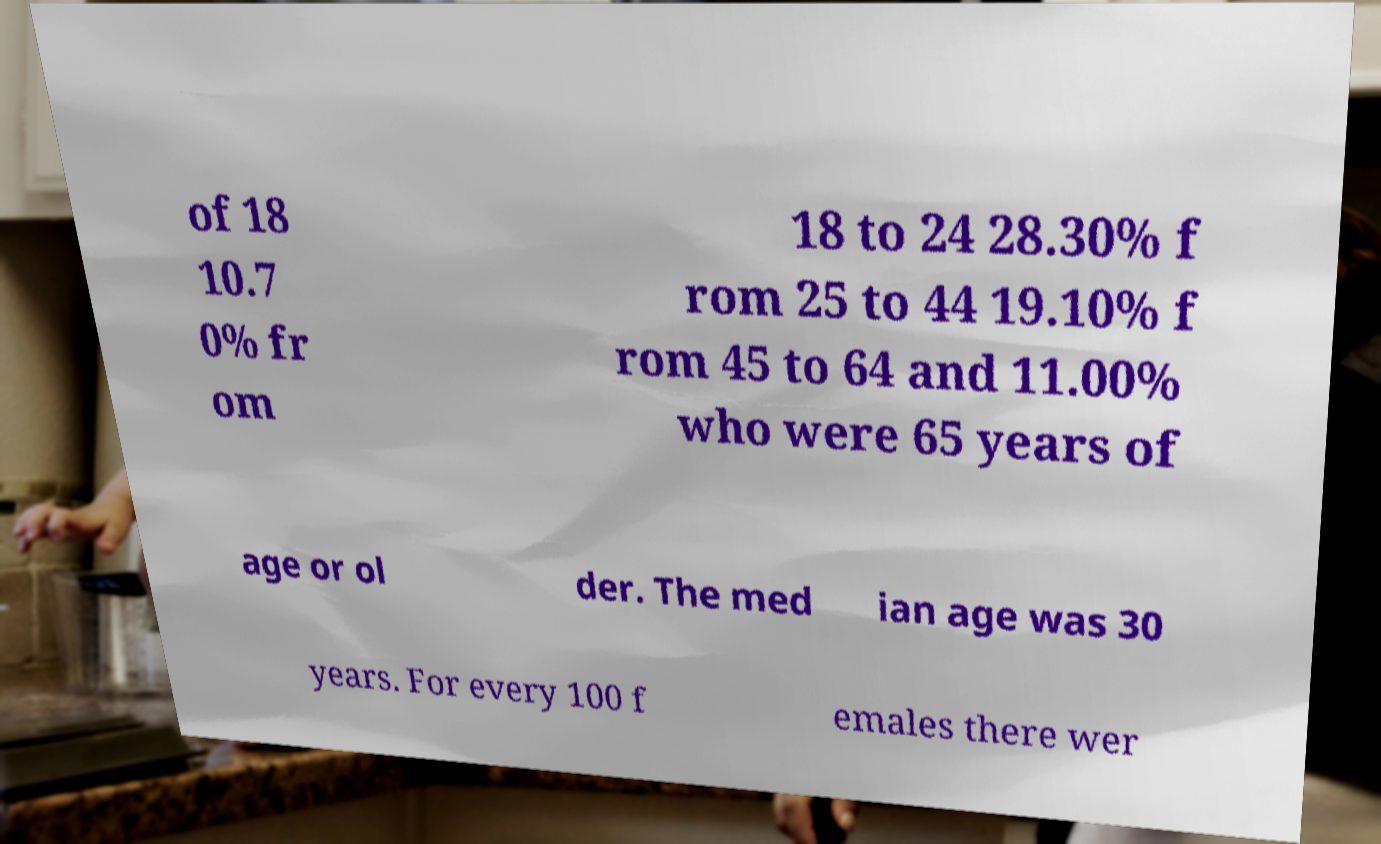For documentation purposes, I need the text within this image transcribed. Could you provide that? of 18 10.7 0% fr om 18 to 24 28.30% f rom 25 to 44 19.10% f rom 45 to 64 and 11.00% who were 65 years of age or ol der. The med ian age was 30 years. For every 100 f emales there wer 